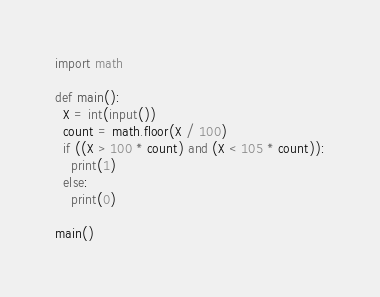Convert code to text. <code><loc_0><loc_0><loc_500><loc_500><_Python_>import math

def main():
  X = int(input())
  count = math.floor(X / 100)
  if ((X > 100 * count) and (X < 105 * count)):
    print(1)
  else:
    print(0)

main()</code> 